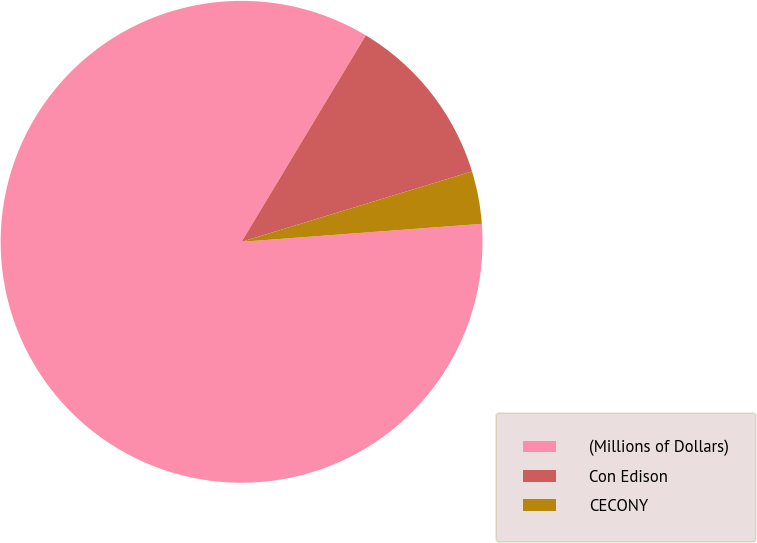Convert chart to OTSL. <chart><loc_0><loc_0><loc_500><loc_500><pie_chart><fcel>(Millions of Dollars)<fcel>Con Edison<fcel>CECONY<nl><fcel>84.81%<fcel>11.66%<fcel>3.53%<nl></chart> 